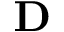<formula> <loc_0><loc_0><loc_500><loc_500>D</formula> 